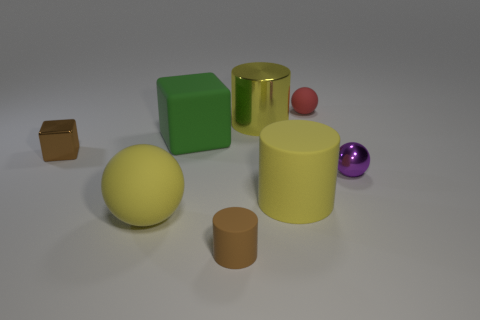Subtract all gray balls. How many yellow cylinders are left? 2 Add 2 small matte spheres. How many objects exist? 10 Subtract all rubber balls. How many balls are left? 1 Subtract all cylinders. How many objects are left? 5 Subtract all brown cubes. Subtract all blue cylinders. How many cubes are left? 1 Subtract all large gray metal things. Subtract all small rubber things. How many objects are left? 6 Add 7 purple spheres. How many purple spheres are left? 8 Add 5 big yellow rubber cylinders. How many big yellow rubber cylinders exist? 6 Subtract 1 red spheres. How many objects are left? 7 